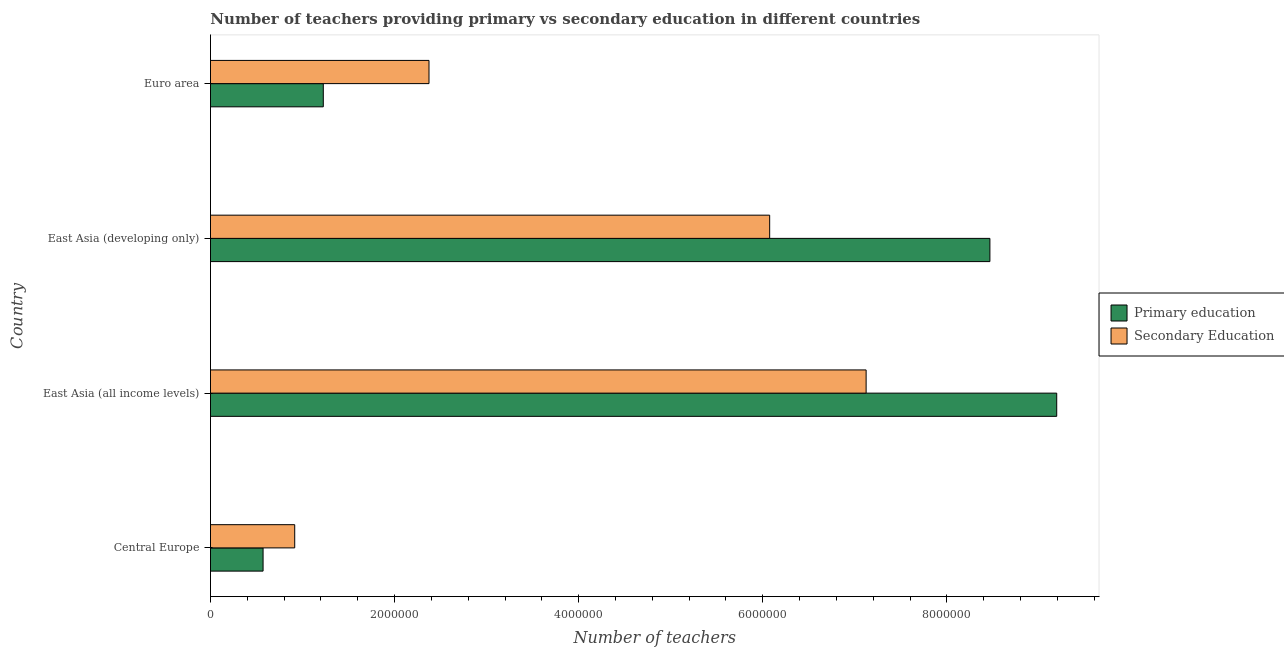How many groups of bars are there?
Provide a succinct answer. 4. Are the number of bars on each tick of the Y-axis equal?
Offer a terse response. Yes. What is the number of secondary teachers in Central Europe?
Keep it short and to the point. 9.15e+05. Across all countries, what is the maximum number of secondary teachers?
Provide a succinct answer. 7.12e+06. Across all countries, what is the minimum number of primary teachers?
Your answer should be very brief. 5.71e+05. In which country was the number of secondary teachers maximum?
Offer a terse response. East Asia (all income levels). In which country was the number of secondary teachers minimum?
Your answer should be compact. Central Europe. What is the total number of primary teachers in the graph?
Offer a terse response. 1.95e+07. What is the difference between the number of primary teachers in Central Europe and that in East Asia (all income levels)?
Provide a short and direct response. -8.62e+06. What is the difference between the number of primary teachers in Euro area and the number of secondary teachers in East Asia (all income levels)?
Keep it short and to the point. -5.90e+06. What is the average number of primary teachers per country?
Provide a short and direct response. 4.86e+06. What is the difference between the number of primary teachers and number of secondary teachers in East Asia (all income levels)?
Offer a terse response. 2.07e+06. What is the ratio of the number of secondary teachers in Central Europe to that in East Asia (developing only)?
Your answer should be very brief. 0.15. Is the difference between the number of secondary teachers in East Asia (all income levels) and East Asia (developing only) greater than the difference between the number of primary teachers in East Asia (all income levels) and East Asia (developing only)?
Your answer should be very brief. Yes. What is the difference between the highest and the second highest number of secondary teachers?
Give a very brief answer. 1.05e+06. What is the difference between the highest and the lowest number of primary teachers?
Provide a succinct answer. 8.62e+06. Is the sum of the number of secondary teachers in Central Europe and East Asia (all income levels) greater than the maximum number of primary teachers across all countries?
Offer a very short reply. No. What does the 2nd bar from the bottom in East Asia (developing only) represents?
Your answer should be compact. Secondary Education. How many bars are there?
Your response must be concise. 8. Are all the bars in the graph horizontal?
Give a very brief answer. Yes. How many countries are there in the graph?
Your answer should be very brief. 4. Are the values on the major ticks of X-axis written in scientific E-notation?
Your answer should be compact. No. Does the graph contain grids?
Offer a terse response. No. How many legend labels are there?
Give a very brief answer. 2. How are the legend labels stacked?
Your answer should be very brief. Vertical. What is the title of the graph?
Give a very brief answer. Number of teachers providing primary vs secondary education in different countries. Does "Male population" appear as one of the legend labels in the graph?
Offer a very short reply. No. What is the label or title of the X-axis?
Your answer should be very brief. Number of teachers. What is the Number of teachers of Primary education in Central Europe?
Your answer should be very brief. 5.71e+05. What is the Number of teachers in Secondary Education in Central Europe?
Your response must be concise. 9.15e+05. What is the Number of teachers of Primary education in East Asia (all income levels)?
Offer a terse response. 9.19e+06. What is the Number of teachers of Secondary Education in East Asia (all income levels)?
Your answer should be compact. 7.12e+06. What is the Number of teachers in Primary education in East Asia (developing only)?
Keep it short and to the point. 8.47e+06. What is the Number of teachers in Secondary Education in East Asia (developing only)?
Make the answer very short. 6.08e+06. What is the Number of teachers of Primary education in Euro area?
Your response must be concise. 1.23e+06. What is the Number of teachers of Secondary Education in Euro area?
Ensure brevity in your answer.  2.37e+06. Across all countries, what is the maximum Number of teachers of Primary education?
Ensure brevity in your answer.  9.19e+06. Across all countries, what is the maximum Number of teachers of Secondary Education?
Give a very brief answer. 7.12e+06. Across all countries, what is the minimum Number of teachers of Primary education?
Keep it short and to the point. 5.71e+05. Across all countries, what is the minimum Number of teachers in Secondary Education?
Offer a very short reply. 9.15e+05. What is the total Number of teachers in Primary education in the graph?
Your response must be concise. 1.95e+07. What is the total Number of teachers of Secondary Education in the graph?
Your response must be concise. 1.65e+07. What is the difference between the Number of teachers in Primary education in Central Europe and that in East Asia (all income levels)?
Make the answer very short. -8.62e+06. What is the difference between the Number of teachers of Secondary Education in Central Europe and that in East Asia (all income levels)?
Give a very brief answer. -6.21e+06. What is the difference between the Number of teachers in Primary education in Central Europe and that in East Asia (developing only)?
Ensure brevity in your answer.  -7.90e+06. What is the difference between the Number of teachers in Secondary Education in Central Europe and that in East Asia (developing only)?
Keep it short and to the point. -5.16e+06. What is the difference between the Number of teachers of Primary education in Central Europe and that in Euro area?
Provide a short and direct response. -6.54e+05. What is the difference between the Number of teachers of Secondary Education in Central Europe and that in Euro area?
Offer a terse response. -1.46e+06. What is the difference between the Number of teachers of Primary education in East Asia (all income levels) and that in East Asia (developing only)?
Ensure brevity in your answer.  7.26e+05. What is the difference between the Number of teachers in Secondary Education in East Asia (all income levels) and that in East Asia (developing only)?
Your answer should be compact. 1.05e+06. What is the difference between the Number of teachers in Primary education in East Asia (all income levels) and that in Euro area?
Offer a very short reply. 7.97e+06. What is the difference between the Number of teachers of Secondary Education in East Asia (all income levels) and that in Euro area?
Ensure brevity in your answer.  4.75e+06. What is the difference between the Number of teachers of Primary education in East Asia (developing only) and that in Euro area?
Your answer should be very brief. 7.24e+06. What is the difference between the Number of teachers of Secondary Education in East Asia (developing only) and that in Euro area?
Provide a short and direct response. 3.70e+06. What is the difference between the Number of teachers of Primary education in Central Europe and the Number of teachers of Secondary Education in East Asia (all income levels)?
Give a very brief answer. -6.55e+06. What is the difference between the Number of teachers in Primary education in Central Europe and the Number of teachers in Secondary Education in East Asia (developing only)?
Make the answer very short. -5.50e+06. What is the difference between the Number of teachers of Primary education in Central Europe and the Number of teachers of Secondary Education in Euro area?
Make the answer very short. -1.80e+06. What is the difference between the Number of teachers in Primary education in East Asia (all income levels) and the Number of teachers in Secondary Education in East Asia (developing only)?
Give a very brief answer. 3.12e+06. What is the difference between the Number of teachers in Primary education in East Asia (all income levels) and the Number of teachers in Secondary Education in Euro area?
Offer a terse response. 6.82e+06. What is the difference between the Number of teachers in Primary education in East Asia (developing only) and the Number of teachers in Secondary Education in Euro area?
Provide a succinct answer. 6.09e+06. What is the average Number of teachers of Primary education per country?
Offer a terse response. 4.86e+06. What is the average Number of teachers in Secondary Education per country?
Offer a terse response. 4.12e+06. What is the difference between the Number of teachers in Primary education and Number of teachers in Secondary Education in Central Europe?
Your answer should be very brief. -3.44e+05. What is the difference between the Number of teachers in Primary education and Number of teachers in Secondary Education in East Asia (all income levels)?
Make the answer very short. 2.07e+06. What is the difference between the Number of teachers of Primary education and Number of teachers of Secondary Education in East Asia (developing only)?
Provide a succinct answer. 2.39e+06. What is the difference between the Number of teachers in Primary education and Number of teachers in Secondary Education in Euro area?
Provide a succinct answer. -1.15e+06. What is the ratio of the Number of teachers in Primary education in Central Europe to that in East Asia (all income levels)?
Your response must be concise. 0.06. What is the ratio of the Number of teachers in Secondary Education in Central Europe to that in East Asia (all income levels)?
Give a very brief answer. 0.13. What is the ratio of the Number of teachers of Primary education in Central Europe to that in East Asia (developing only)?
Provide a short and direct response. 0.07. What is the ratio of the Number of teachers of Secondary Education in Central Europe to that in East Asia (developing only)?
Offer a terse response. 0.15. What is the ratio of the Number of teachers in Primary education in Central Europe to that in Euro area?
Provide a succinct answer. 0.47. What is the ratio of the Number of teachers of Secondary Education in Central Europe to that in Euro area?
Provide a short and direct response. 0.39. What is the ratio of the Number of teachers of Primary education in East Asia (all income levels) to that in East Asia (developing only)?
Offer a very short reply. 1.09. What is the ratio of the Number of teachers of Secondary Education in East Asia (all income levels) to that in East Asia (developing only)?
Make the answer very short. 1.17. What is the ratio of the Number of teachers of Primary education in East Asia (all income levels) to that in Euro area?
Your answer should be very brief. 7.5. What is the ratio of the Number of teachers of Secondary Education in East Asia (all income levels) to that in Euro area?
Offer a terse response. 3. What is the ratio of the Number of teachers in Primary education in East Asia (developing only) to that in Euro area?
Your answer should be compact. 6.91. What is the ratio of the Number of teachers of Secondary Education in East Asia (developing only) to that in Euro area?
Keep it short and to the point. 2.56. What is the difference between the highest and the second highest Number of teachers in Primary education?
Provide a short and direct response. 7.26e+05. What is the difference between the highest and the second highest Number of teachers in Secondary Education?
Ensure brevity in your answer.  1.05e+06. What is the difference between the highest and the lowest Number of teachers of Primary education?
Your answer should be very brief. 8.62e+06. What is the difference between the highest and the lowest Number of teachers of Secondary Education?
Your answer should be very brief. 6.21e+06. 